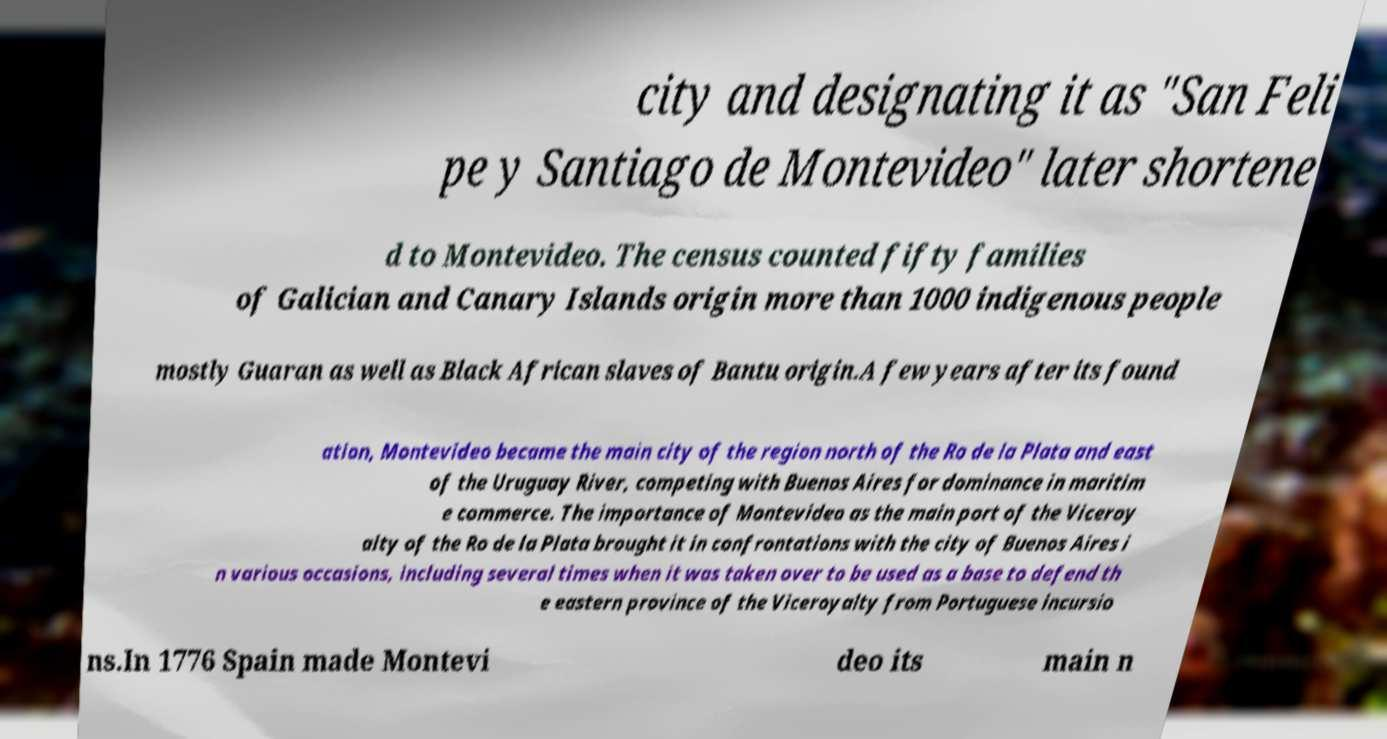What messages or text are displayed in this image? I need them in a readable, typed format. city and designating it as "San Feli pe y Santiago de Montevideo" later shortene d to Montevideo. The census counted fifty families of Galician and Canary Islands origin more than 1000 indigenous people mostly Guaran as well as Black African slaves of Bantu origin.A few years after its found ation, Montevideo became the main city of the region north of the Ro de la Plata and east of the Uruguay River, competing with Buenos Aires for dominance in maritim e commerce. The importance of Montevideo as the main port of the Viceroy alty of the Ro de la Plata brought it in confrontations with the city of Buenos Aires i n various occasions, including several times when it was taken over to be used as a base to defend th e eastern province of the Viceroyalty from Portuguese incursio ns.In 1776 Spain made Montevi deo its main n 